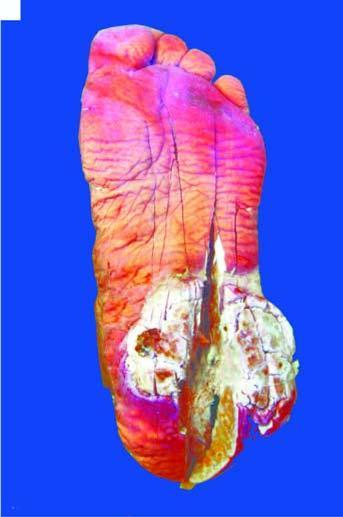does the skin surface on the sole of the foot show a fungating and ulcerated growth?
Answer the question using a single word or phrase. Yes 